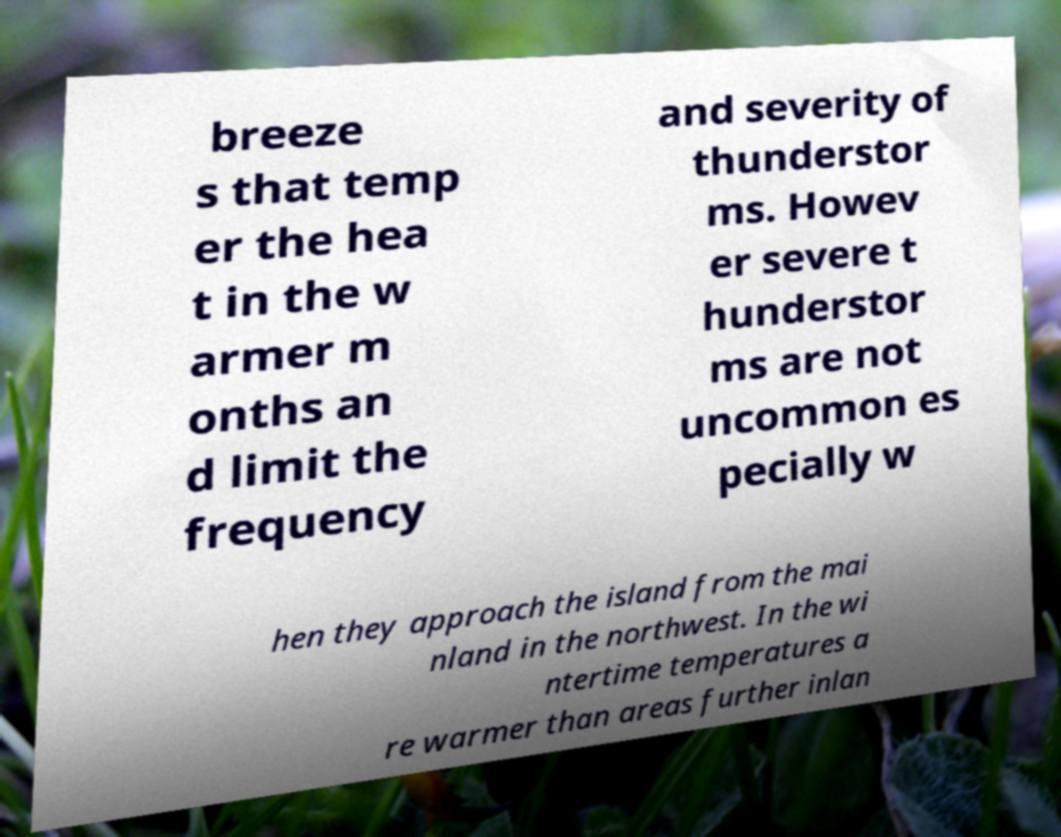Could you extract and type out the text from this image? breeze s that temp er the hea t in the w armer m onths an d limit the frequency and severity of thunderstor ms. Howev er severe t hunderstor ms are not uncommon es pecially w hen they approach the island from the mai nland in the northwest. In the wi ntertime temperatures a re warmer than areas further inlan 